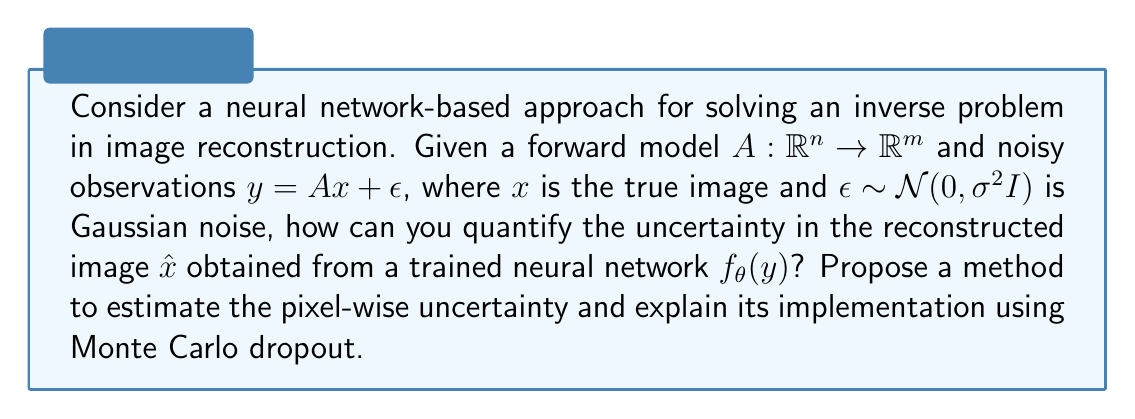Help me with this question. To quantify uncertainty in the reconstructed image using neural networks, we can employ Monte Carlo dropout. Here's a step-by-step explanation:

1. Train a neural network $f_\theta(y)$ to map noisy observations $y$ to reconstructed images $\hat{x}$.

2. Implement Monte Carlo dropout:
   a. During inference, keep dropout layers active.
   b. Perform $T$ forward passes through the network for each input $y$.

3. For each pixel $i$ in the image, collect the $T$ predictions:
   $$\{\hat{x}_i^{(1)}, \hat{x}_i^{(2)}, ..., \hat{x}_i^{(T)}\}$$

4. Estimate the mean reconstructed value for pixel $i$:
   $$\mu_i = \frac{1}{T} \sum_{t=1}^T \hat{x}_i^{(t)}$$

5. Estimate the variance (uncertainty) for pixel $i$:
   $$\sigma_i^2 = \frac{1}{T-1} \sum_{t=1}^T (\hat{x}_i^{(t)} - \mu_i)^2$$

6. The pixel-wise uncertainty can be represented by the standard deviation:
   $$\sigma_i = \sqrt{\sigma_i^2}$$

This method provides an estimate of the uncertainty for each pixel in the reconstructed image, allowing for a comprehensive uncertainty quantification in the inverse problem solution.
Answer: Monte Carlo dropout with $T$ forward passes, calculating pixel-wise mean $\mu_i$ and standard deviation $\sigma_i$. 